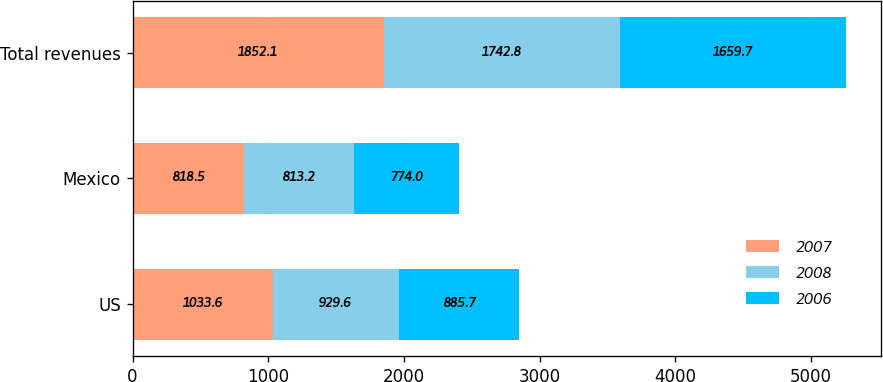Convert chart. <chart><loc_0><loc_0><loc_500><loc_500><stacked_bar_chart><ecel><fcel>US<fcel>Mexico<fcel>Total revenues<nl><fcel>2007<fcel>1033.6<fcel>818.5<fcel>1852.1<nl><fcel>2008<fcel>929.6<fcel>813.2<fcel>1742.8<nl><fcel>2006<fcel>885.7<fcel>774<fcel>1659.7<nl></chart> 